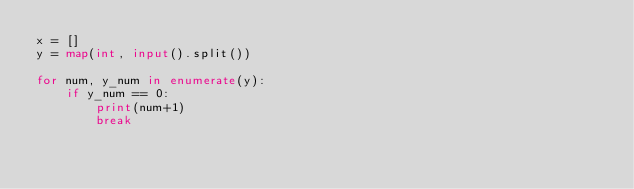<code> <loc_0><loc_0><loc_500><loc_500><_Python_>x = []
y = map(int, input().split())

for num, y_num in enumerate(y):
    if y_num == 0:
        print(num+1)
        break</code> 